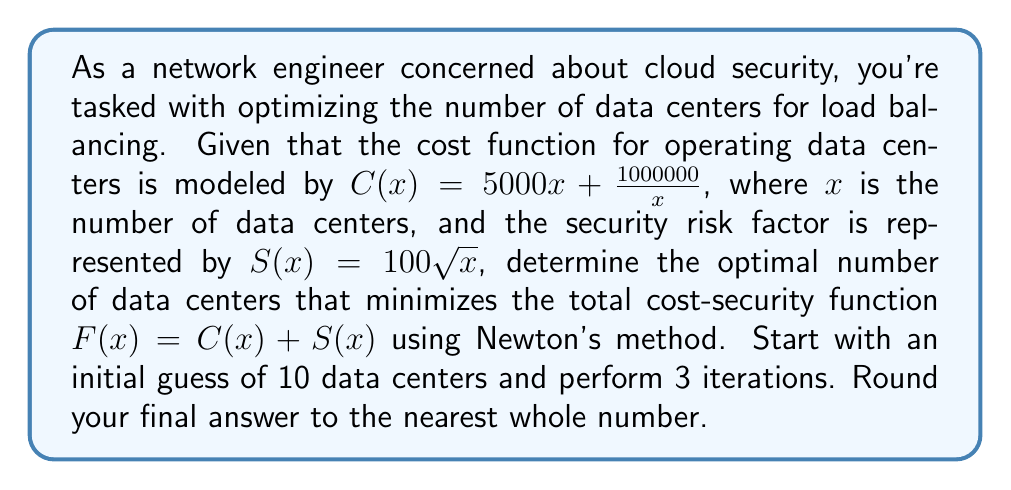Could you help me with this problem? 1) The total cost-security function is:
   $$F(x) = C(x) + S(x) = 5000x + \frac{1000000}{x} + 100\sqrt{x}$$

2) To apply Newton's method, we need $F'(x)$ and $F''(x)$:
   $$F'(x) = 5000 - \frac{1000000}{x^2} + \frac{50}{\sqrt{x}}$$
   $$F''(x) = \frac{2000000}{x^3} - \frac{25}{x\sqrt{x}}$$

3) Newton's method formula:
   $$x_{n+1} = x_n - \frac{F'(x_n)}{F''(x_n)}$$

4) Starting with $x_0 = 10$, let's perform 3 iterations:

   Iteration 1:
   $$x_1 = 10 - \frac{5000 - \frac{1000000}{100} + \frac{50}{\sqrt{10}}}{\frac{2000000}{1000} - \frac{25}{10\sqrt{10}}} \approx 14.1421$$

   Iteration 2:
   $$x_2 = 14.1421 - \frac{5000 - \frac{1000000}{(14.1421)^2} + \frac{50}{\sqrt{14.1421}}}{\frac{2000000}{(14.1421)^3} - \frac{25}{14.1421\sqrt{14.1421}}} \approx 14.1422$$

   Iteration 3:
   $$x_3 = 14.1422 - \frac{5000 - \frac{1000000}{(14.1422)^2} + \frac{50}{\sqrt{14.1422}}}{\frac{2000000}{(14.1422)^3} - \frac{25}{14.1422\sqrt{14.1422}}} \approx 14.1422$$

5) Rounding to the nearest whole number: 14
Answer: 14 data centers 